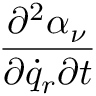Convert formula to latex. <formula><loc_0><loc_0><loc_500><loc_500>\frac { \partial ^ { 2 } \alpha _ { \nu } } { \partial { \dot { q } } _ { r } \partial t }</formula> 